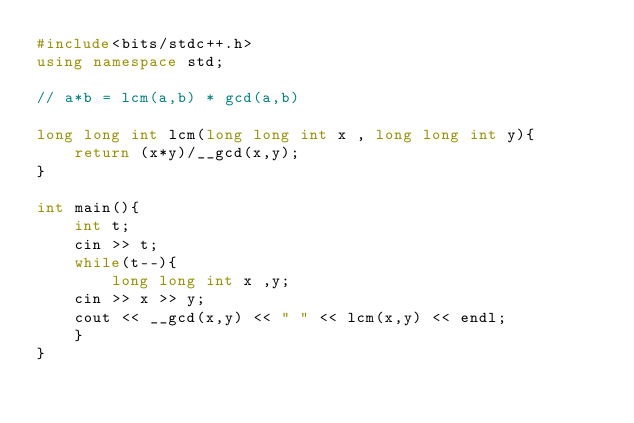Convert code to text. <code><loc_0><loc_0><loc_500><loc_500><_C++_>#include<bits/stdc++.h>
using namespace std;

// a*b = lcm(a,b) * gcd(a,b)

long long int lcm(long long int x , long long int y){
    return (x*y)/__gcd(x,y);
}

int main(){
    int t;
    cin >> t;
    while(t--){
        long long int x ,y;
    cin >> x >> y;
    cout << __gcd(x,y) << " " << lcm(x,y) << endl;
    }
}
</code> 